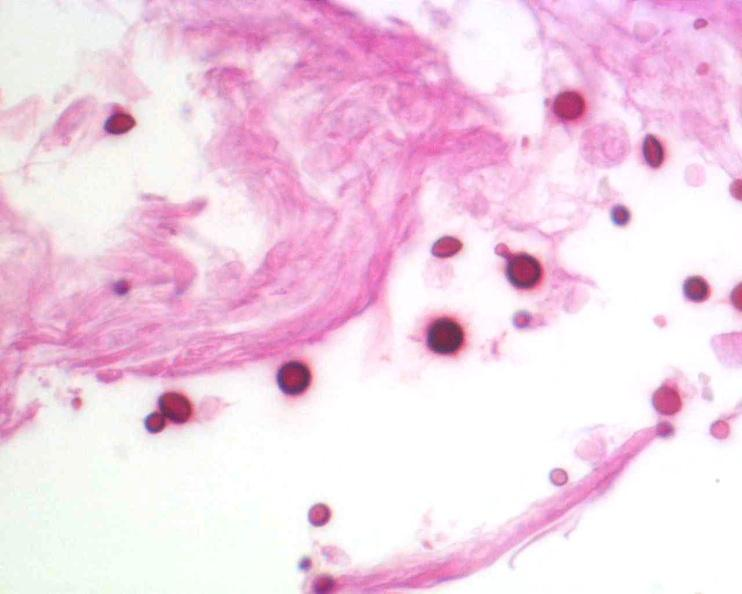does this image show brain, cryptococcal meningitis, pas stain?
Answer the question using a single word or phrase. Yes 